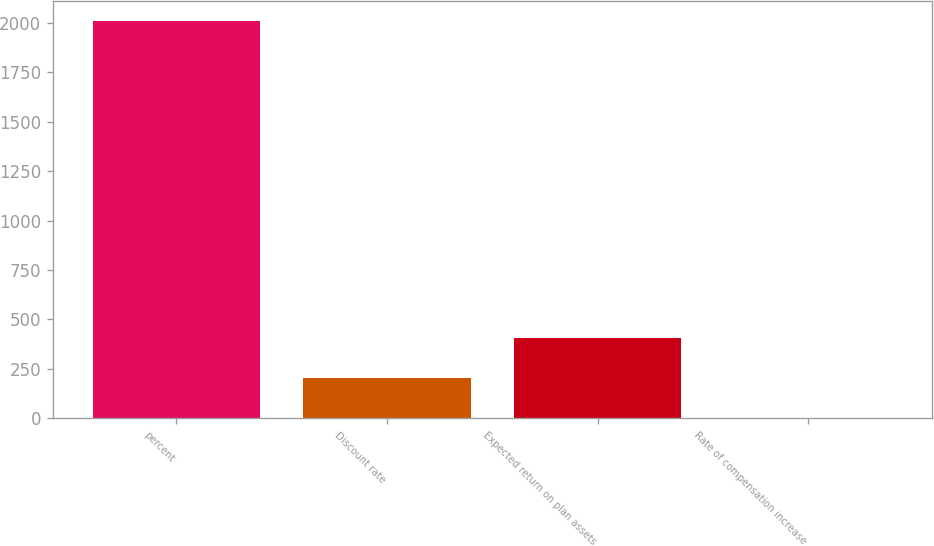Convert chart. <chart><loc_0><loc_0><loc_500><loc_500><bar_chart><fcel>percent<fcel>Discount rate<fcel>Expected return on plan assets<fcel>Rate of compensation increase<nl><fcel>2011<fcel>203.62<fcel>404.44<fcel>2.8<nl></chart> 